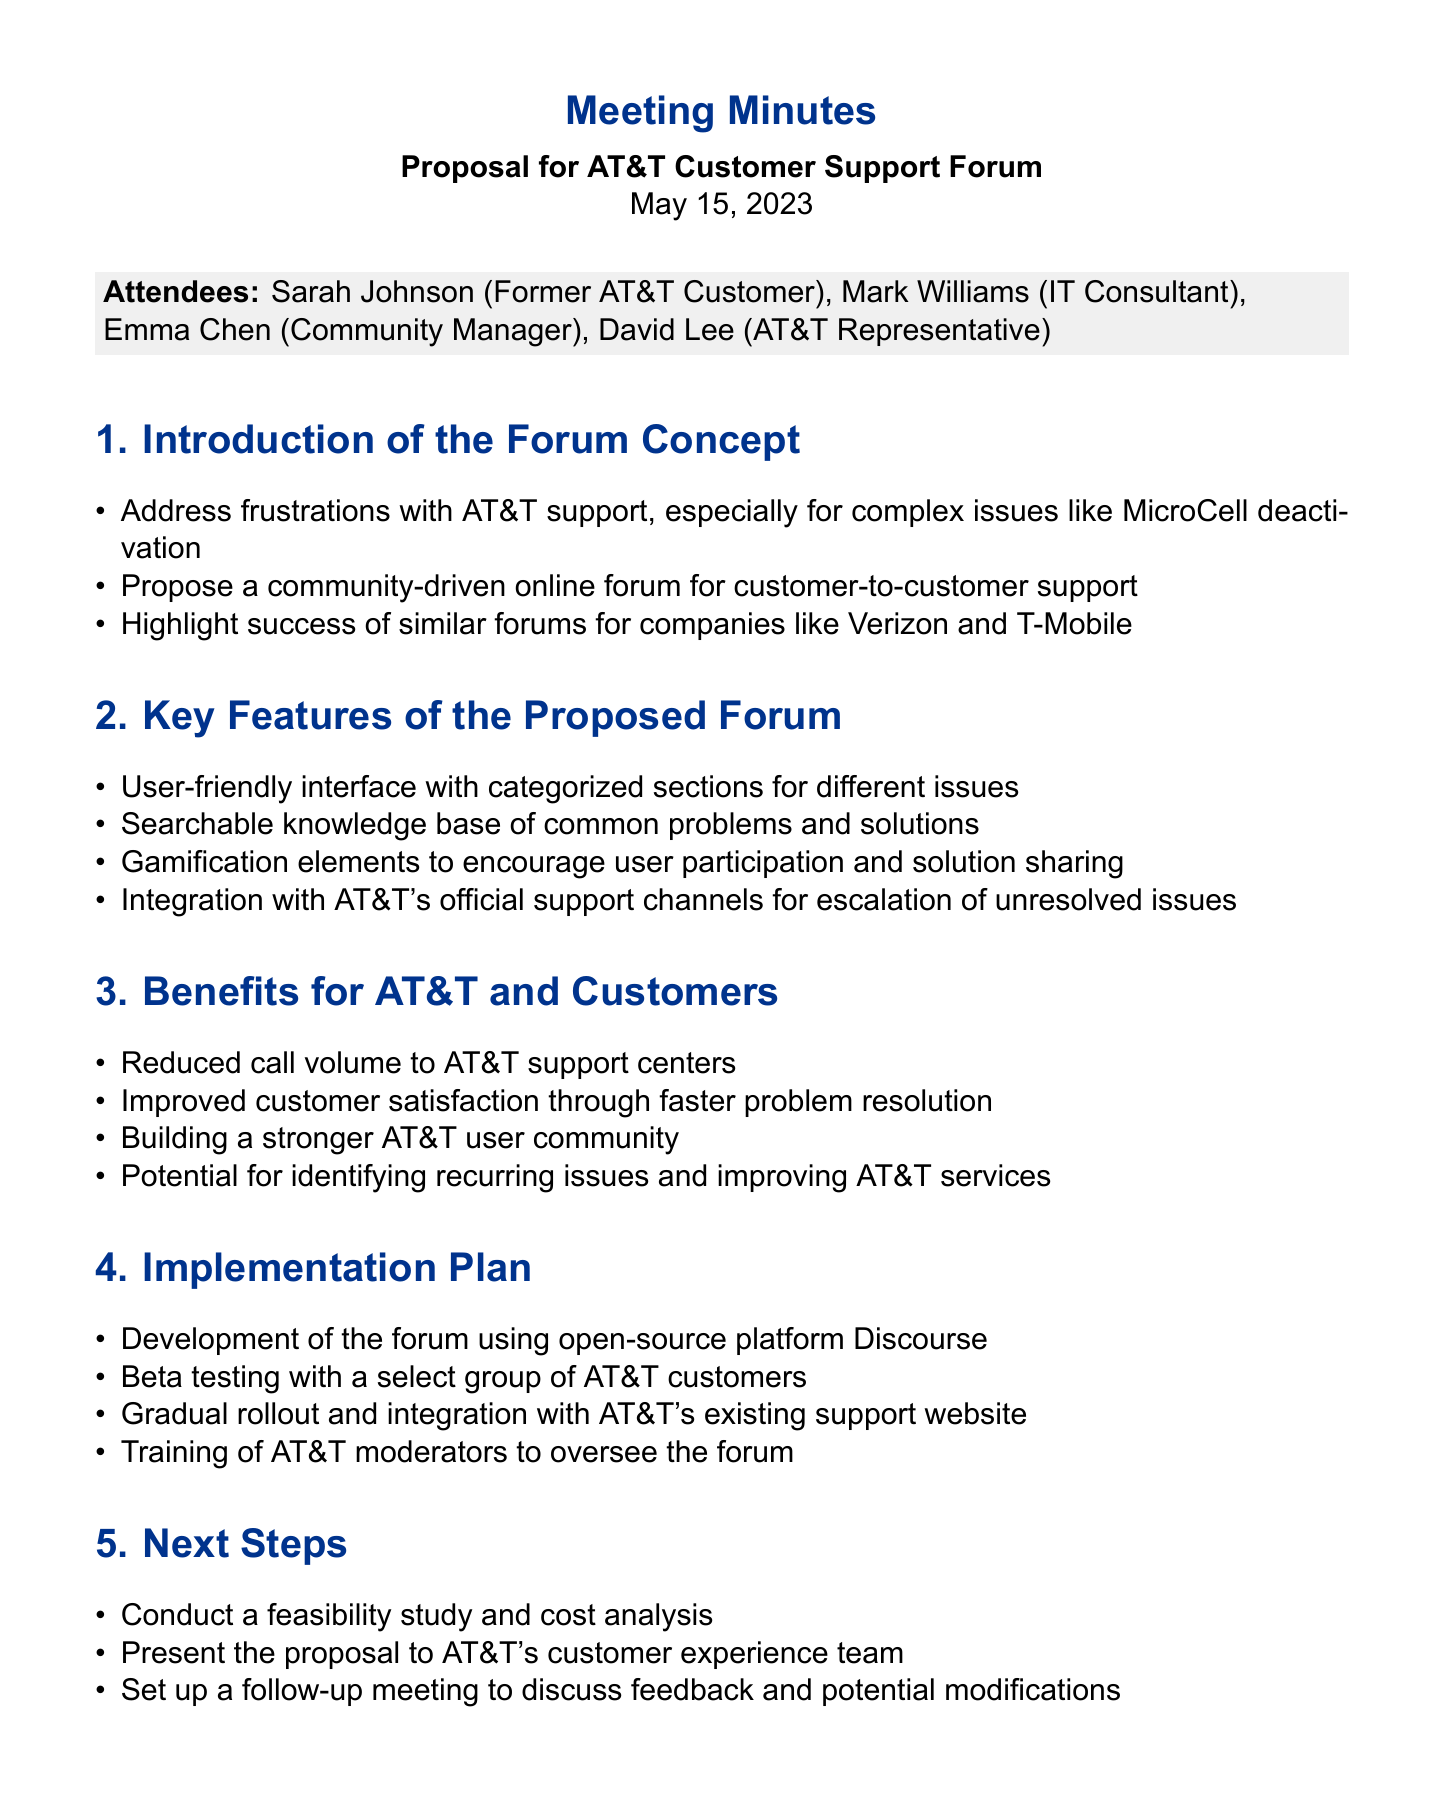What is the date of the meeting? The document states that the meeting took place on May 15, 2023.
Answer: May 15, 2023 Who proposed the community-driven online forum? The proposal was introduced by Sarah Johnson, who is a former AT&T customer.
Answer: Sarah Johnson What is one of the key features of the proposed forum? The document lists a user-friendly interface with categorized sections as a key feature.
Answer: User-friendly interface What platform will the forum be developed on? The minutes specify that the forum will be developed using the open-source platform Discourse.
Answer: Discourse What is one expected benefit for AT&T mentioned in the document? One expected benefit listed is reduced call volume to AT&T support centers.
Answer: Reduced call volume What will be done during the beta testing phase? The minutes indicate that beta testing will involve a select group of AT&T customers.
Answer: A select group of AT&T customers How will the forum be integrated with AT&T's existing services? The document mentions integration with AT&T's official support channels for escalation of unresolved issues.
Answer: Integration with official support channels What is the purpose of the feasibility study? The feasibility study aims to assess the practicality and cost-effectiveness of the proposed forum.
Answer: Assess practicality and cost-effectiveness Who is responsible for overseeing the forum? The training of AT&T moderators to oversee the forum is mentioned in the implementation plan.
Answer: AT&T moderators 